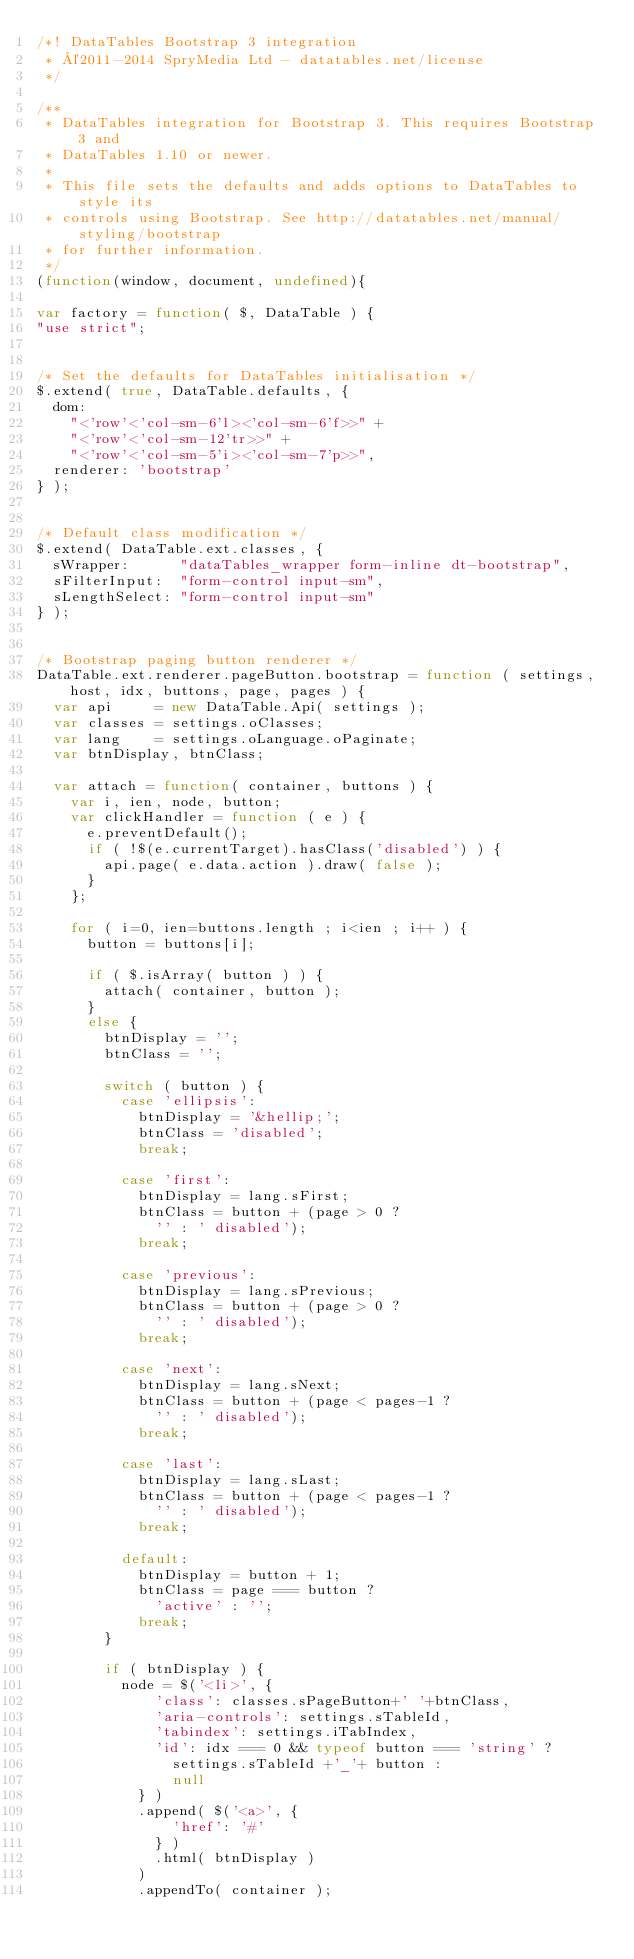<code> <loc_0><loc_0><loc_500><loc_500><_JavaScript_>/*! DataTables Bootstrap 3 integration
 * ©2011-2014 SpryMedia Ltd - datatables.net/license
 */

/**
 * DataTables integration for Bootstrap 3. This requires Bootstrap 3 and
 * DataTables 1.10 or newer.
 *
 * This file sets the defaults and adds options to DataTables to style its
 * controls using Bootstrap. See http://datatables.net/manual/styling/bootstrap
 * for further information.
 */
(function(window, document, undefined){

var factory = function( $, DataTable ) {
"use strict";


/* Set the defaults for DataTables initialisation */
$.extend( true, DataTable.defaults, {
	dom:
		"<'row'<'col-sm-6'l><'col-sm-6'f>>" +
		"<'row'<'col-sm-12'tr>>" +
		"<'row'<'col-sm-5'i><'col-sm-7'p>>",
	renderer: 'bootstrap'
} );


/* Default class modification */
$.extend( DataTable.ext.classes, {
	sWrapper:      "dataTables_wrapper form-inline dt-bootstrap",
	sFilterInput:  "form-control input-sm",
	sLengthSelect: "form-control input-sm"
} );


/* Bootstrap paging button renderer */
DataTable.ext.renderer.pageButton.bootstrap = function ( settings, host, idx, buttons, page, pages ) {
	var api     = new DataTable.Api( settings );
	var classes = settings.oClasses;
	var lang    = settings.oLanguage.oPaginate;
	var btnDisplay, btnClass;

	var attach = function( container, buttons ) {
		var i, ien, node, button;
		var clickHandler = function ( e ) {
			e.preventDefault();
			if ( !$(e.currentTarget).hasClass('disabled') ) {
				api.page( e.data.action ).draw( false );
			}
		};

		for ( i=0, ien=buttons.length ; i<ien ; i++ ) {
			button = buttons[i];

			if ( $.isArray( button ) ) {
				attach( container, button );
			}
			else {
				btnDisplay = '';
				btnClass = '';

				switch ( button ) {
					case 'ellipsis':
						btnDisplay = '&hellip;';
						btnClass = 'disabled';
						break;

					case 'first':
						btnDisplay = lang.sFirst;
						btnClass = button + (page > 0 ?
							'' : ' disabled');
						break;

					case 'previous':
						btnDisplay = lang.sPrevious;
						btnClass = button + (page > 0 ?
							'' : ' disabled');
						break;

					case 'next':
						btnDisplay = lang.sNext;
						btnClass = button + (page < pages-1 ?
							'' : ' disabled');
						break;

					case 'last':
						btnDisplay = lang.sLast;
						btnClass = button + (page < pages-1 ?
							'' : ' disabled');
						break;

					default:
						btnDisplay = button + 1;
						btnClass = page === button ?
							'active' : '';
						break;
				}

				if ( btnDisplay ) {
					node = $('<li>', {
							'class': classes.sPageButton+' '+btnClass,
							'aria-controls': settings.sTableId,
							'tabindex': settings.iTabIndex,
							'id': idx === 0 && typeof button === 'string' ?
								settings.sTableId +'_'+ button :
								null
						} )
						.append( $('<a>', {
								'href': '#'
							} )
							.html( btnDisplay )
						)
						.appendTo( container );
</code> 